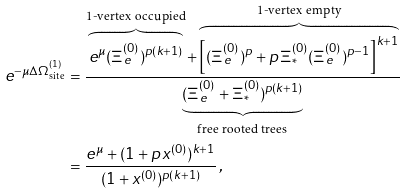Convert formula to latex. <formula><loc_0><loc_0><loc_500><loc_500>e ^ { - \mu \Delta \Omega ^ { ( 1 ) } _ { \text {site} } } & = \frac { \overbrace { e ^ { \mu } ( \Xi _ { e } ^ { ( 0 ) } ) ^ { p ( k + 1 ) } } ^ { \text {1-vertex      occupied} } + \overbrace { \left [ ( \Xi _ { e } ^ { ( 0 ) } ) ^ { p } + p \, \Xi _ { * } ^ { ( 0 ) } ( \Xi _ { e } ^ { ( 0 ) } ) ^ { p - 1 } \right ] ^ { k + 1 } } ^ { \text {1-vertex empty} } } { \underbrace { ( \Xi _ { e } ^ { ( 0 ) } + \Xi _ { * } ^ { ( 0 ) } ) ^ { p ( k + 1 ) } } _ { \text {free         rooted trees} } } \\ & = \frac { e ^ { \mu } + ( 1 + p \, x ^ { ( 0 ) } ) ^ { k + 1 } } { ( 1 + x ^ { ( 0 ) } ) ^ { p ( k + 1 ) } } \, ,</formula> 